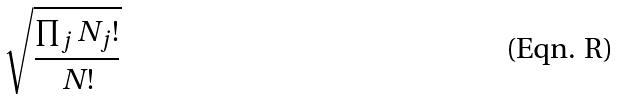Convert formula to latex. <formula><loc_0><loc_0><loc_500><loc_500>\sqrt { \frac { \prod _ { j } N _ { j } ! } { N ! } }</formula> 